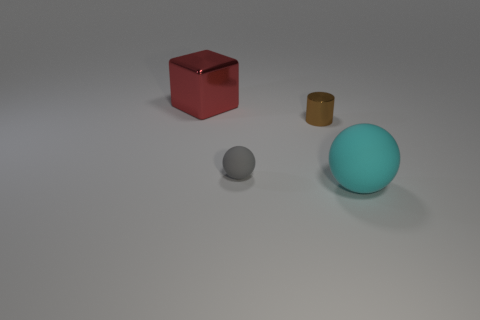Add 1 big gray rubber cylinders. How many objects exist? 5 Subtract all gray spheres. How many spheres are left? 1 Subtract 1 cylinders. How many cylinders are left? 0 Subtract all blocks. How many objects are left? 3 Subtract all red cylinders. How many cyan balls are left? 1 Add 2 tiny gray objects. How many tiny gray objects are left? 3 Add 4 large matte things. How many large matte things exist? 5 Subtract 0 green cylinders. How many objects are left? 4 Subtract all brown blocks. Subtract all purple spheres. How many blocks are left? 1 Subtract all large balls. Subtract all purple metal cylinders. How many objects are left? 3 